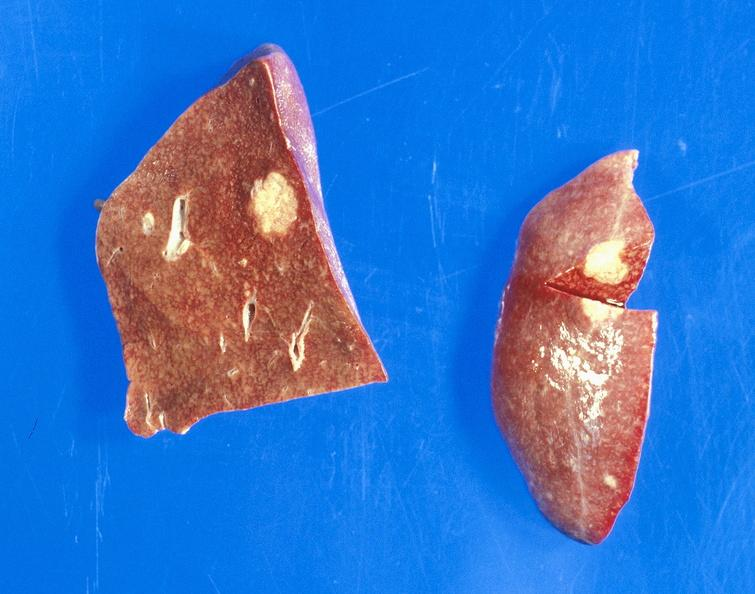s liver present?
Answer the question using a single word or phrase. Yes 